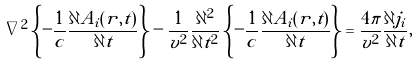Convert formula to latex. <formula><loc_0><loc_0><loc_500><loc_500>\nabla ^ { 2 } \left \{ - \frac { 1 } { c } \frac { \partial { A } _ { i } ( { r } , t ) } { \partial t } \right \} - \frac { 1 } { v ^ { 2 } } \frac { \partial ^ { 2 } } { \partial t ^ { 2 } } \left \{ - \frac { 1 } { c } \frac { \partial { A } _ { i } ( { r } , t ) } { \partial t } \right \} = \frac { 4 \pi } { v ^ { 2 } } \frac { \partial { j } _ { i } } { \partial t } ,</formula> 